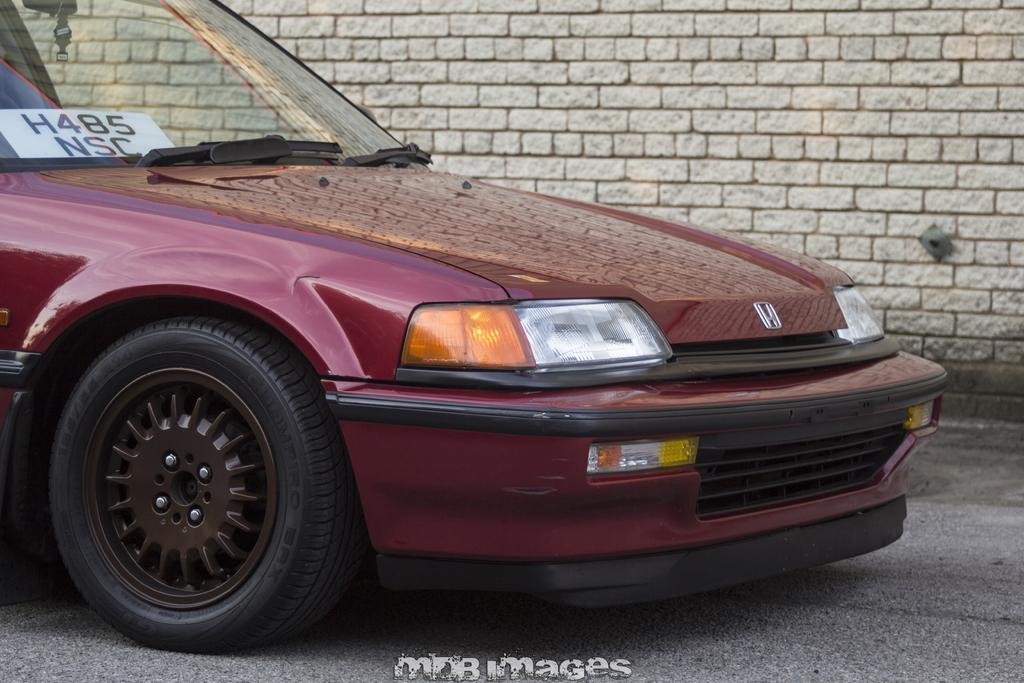Where was the image taken? The image was taken outdoors. What can be seen at the bottom of the image? There is a road at the bottom of the image. What is visible in the background of the image? There is a wall in the background of the image. What is parked on the road on the left side of the image? A car is parked on the road on the left side of the image. How does the disgusting smell affect the image? There is no mention of a smell, disgusting or otherwise, in the image. The image is a visual representation and does not convey smells or emotions. 